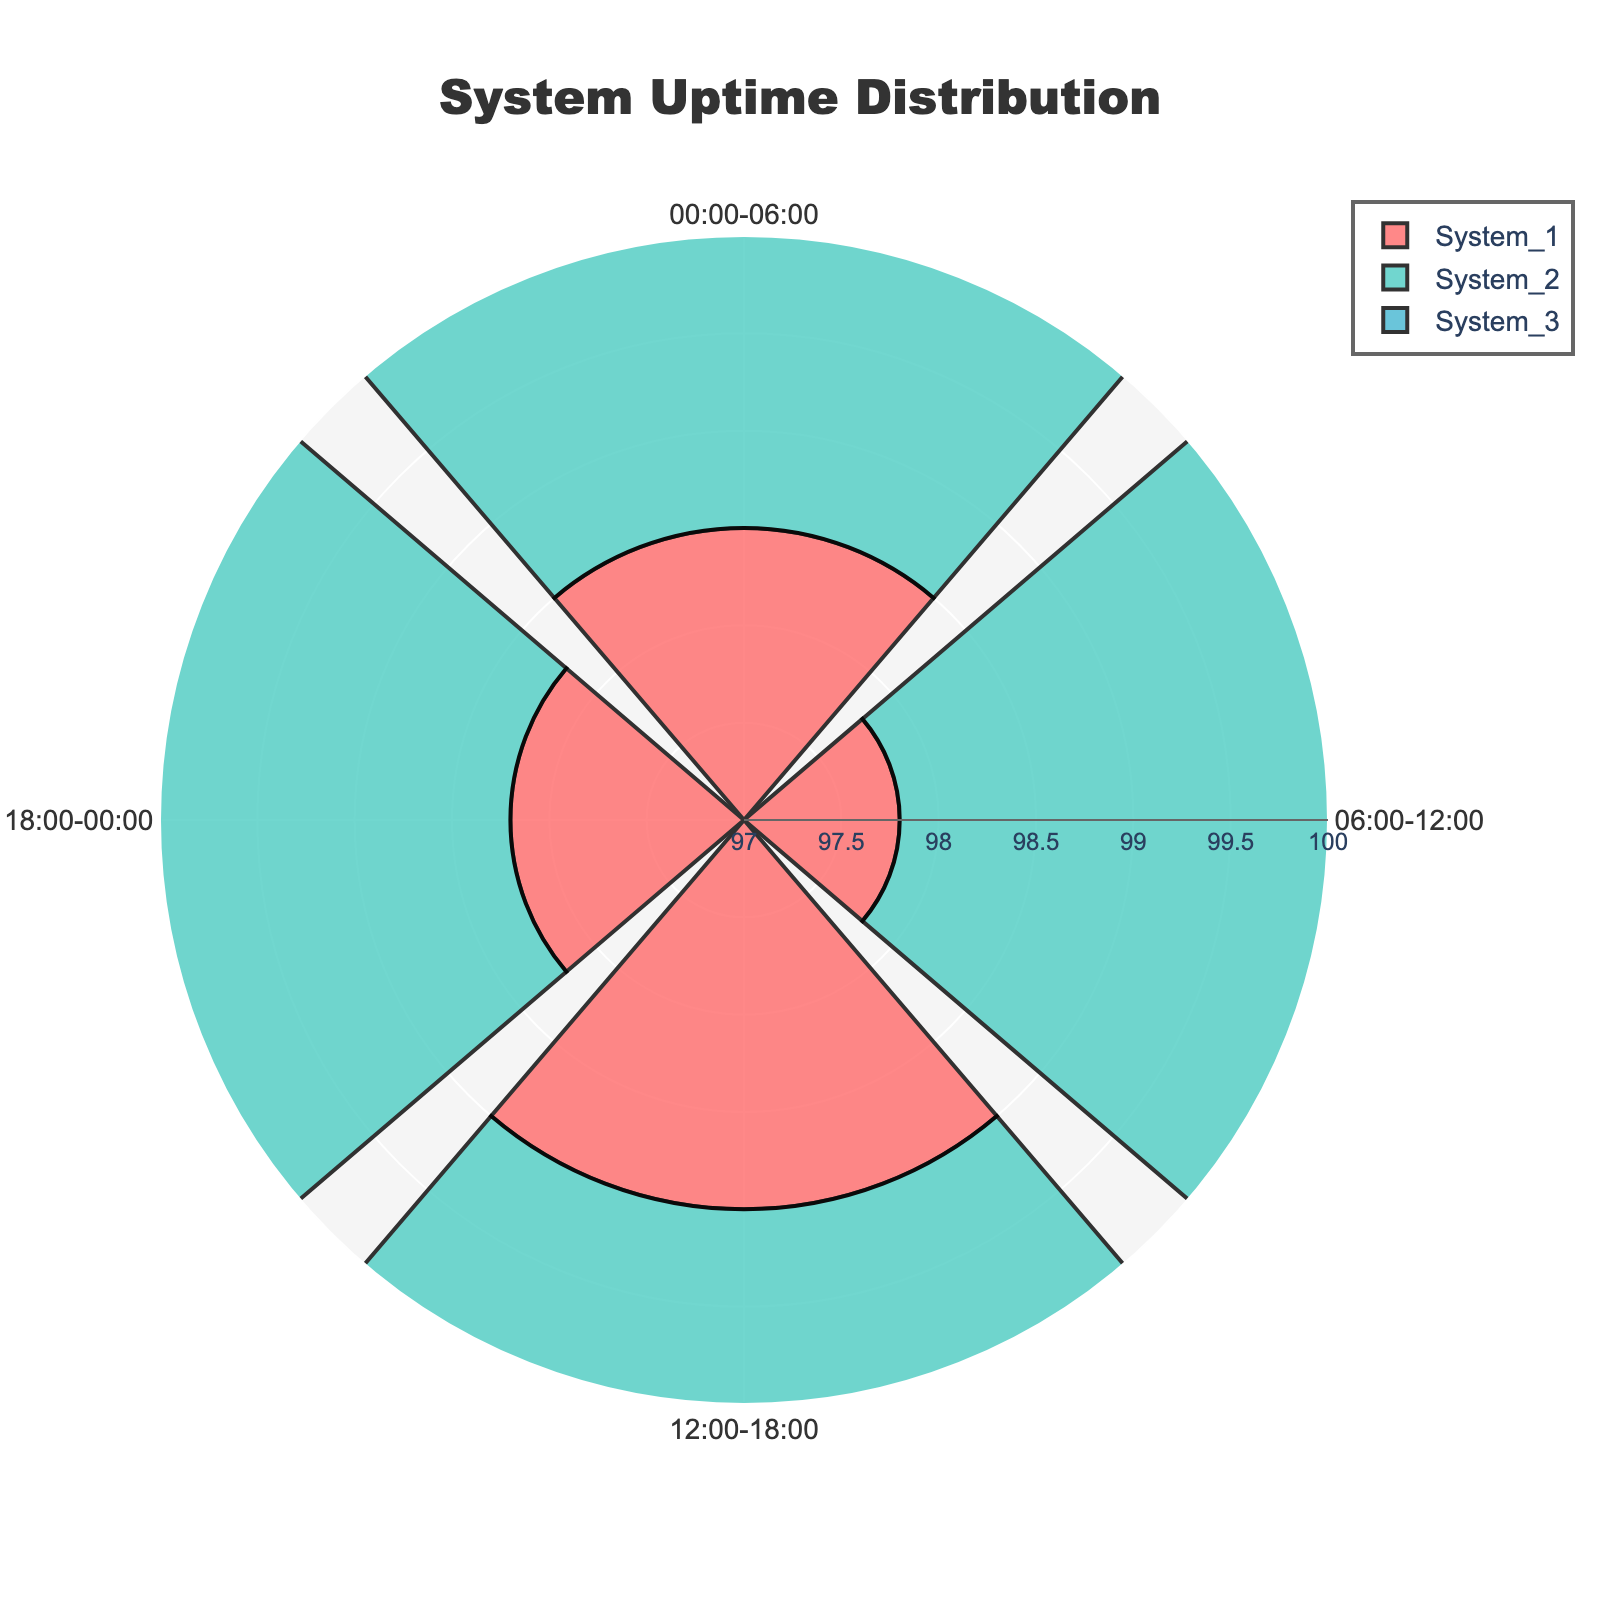What's the title of the figure? The title is displayed at the top center of the figure, usually in a larger and bold font.
Answer: System Uptime Distribution What are the times intervals used in the chart? The time intervals are displayed as categories around the circle. They usually appear at angular positions.
Answer: 00:00-06:00, 06:00-12:00, 12:00-18:00, 18:00-00:00 What's the color used for System_1? The color of each system's trace can be identified by looking at the legend or the bars themselves.
Answer: Red Which system had the highest uptime during 06:00-12:00? We compare the radial lengths for 06:00-12:00 across all systems. The longest bar corresponds to the highest uptime.
Answer: System_2 How does the uptime of System_3 at 18:00-00:00 compare to System_1 at 00:00-06:00? Compare the radial lengths of the bars for the specified systems and time intervals.
Answer: System_3 at 18:00-00:00 is lower than System_1 at 00:00-06:00 What's the average uptime of System_2 across all intervals? We sum the uptime values for System_2 across all intervals and divide by the number of intervals. (99.1 + 98.4 + 98.9 + 99.0) / 4 = 98.85
Answer: 98.85 What's the difference in uptime between System_1 and System_3 during 12:00-18:00? Subtract the uptime value for System_3 from System_1 for the interval 12:00-18:00. 99.2 - 99.0 = 0.2
Answer: 0.2 Which time interval shows the lowest uptime for System_1? Identify the shortest bar for System_1 across all time intervals.
Answer: 06:00-12:00 What's the median uptime value of System_3? Arrange System_3's uptime values in ascending order, then find the middle value. Middle values: 97.6, 98.5, 98.8, 99.2. Median = (98.5 + 98.8) / 2 = 98.65
Answer: 98.65 